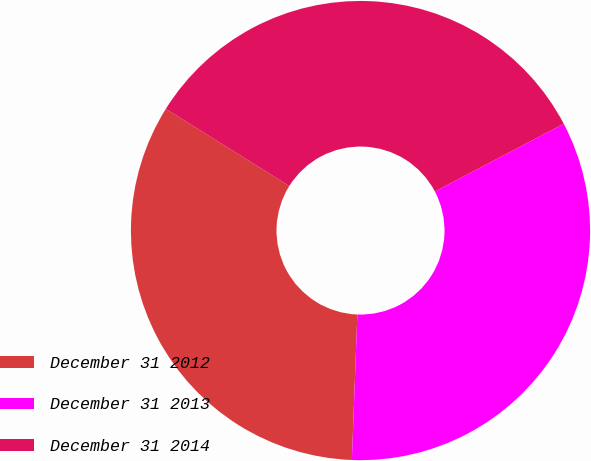Convert chart. <chart><loc_0><loc_0><loc_500><loc_500><pie_chart><fcel>December 31 2012<fcel>December 31 2013<fcel>December 31 2014<nl><fcel>33.29%<fcel>33.3%<fcel>33.41%<nl></chart> 